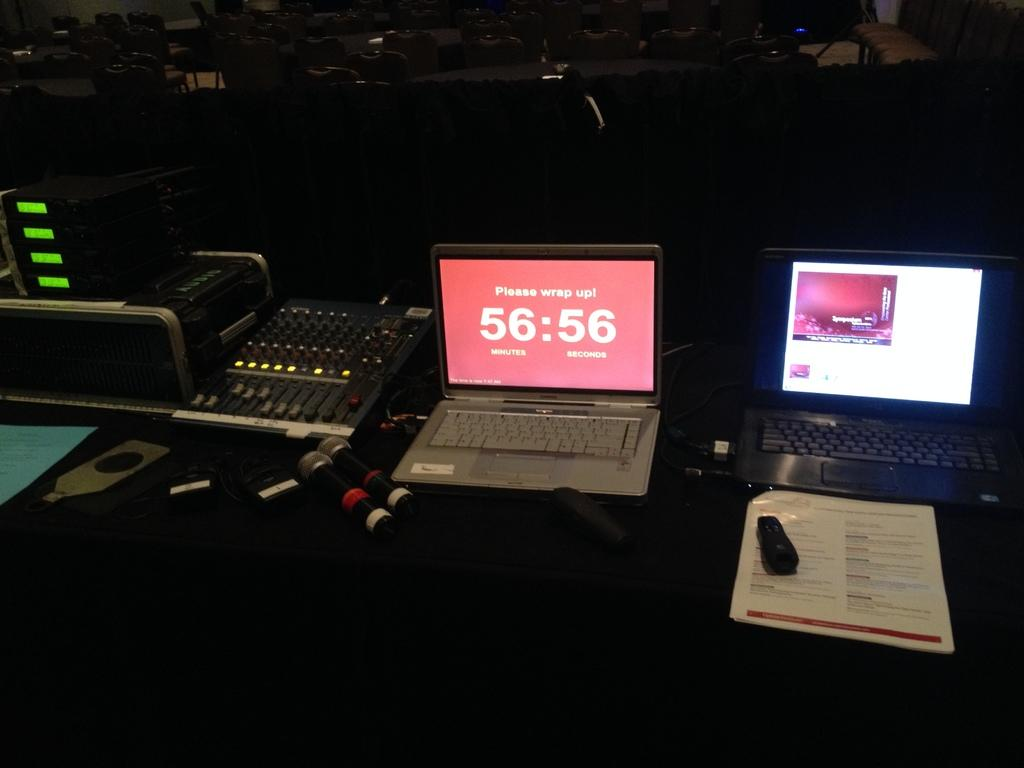Provide a one-sentence caption for the provided image. Two laptops are open and one reads please wrap up in 56:56. 